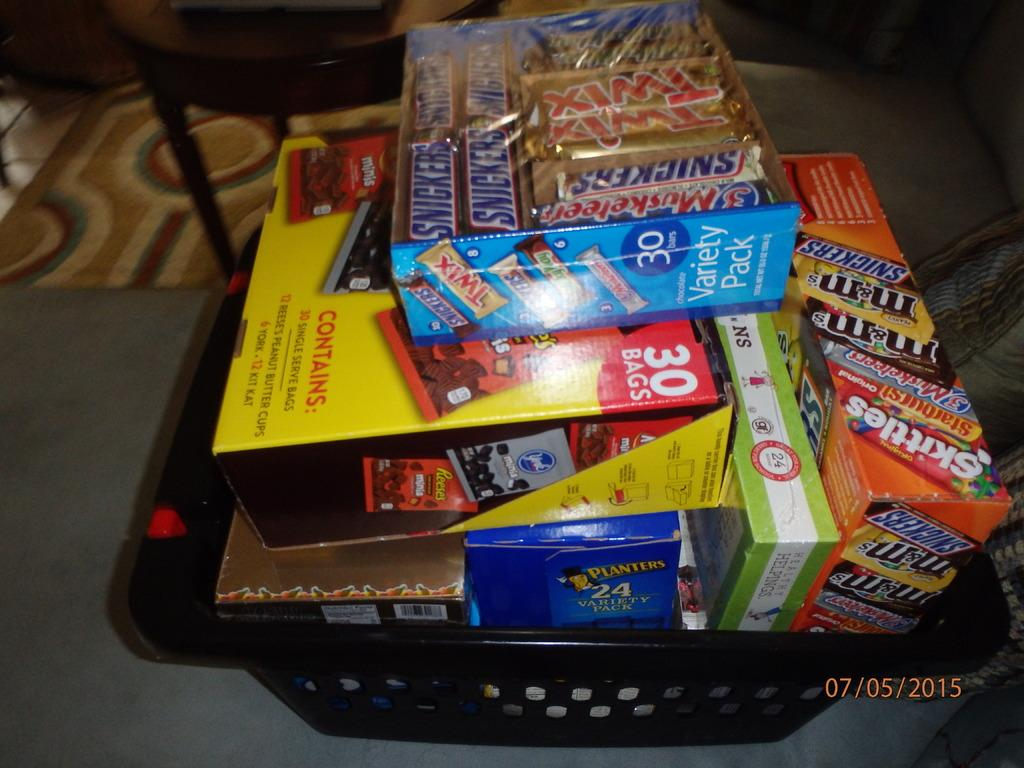Provide a one-sentence caption for the provided image. A basket filled with snacks and candy such as twix, snickers, and skittles. 